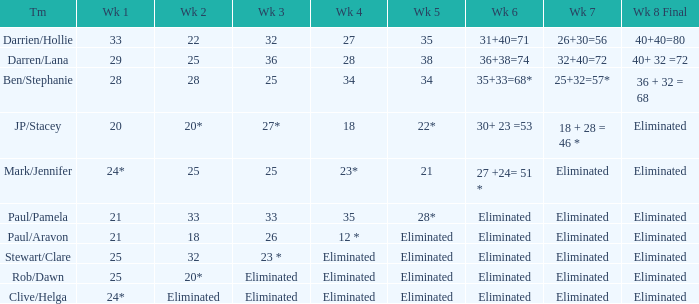Name the team for week 1 of 33 Darrien/Hollie. 